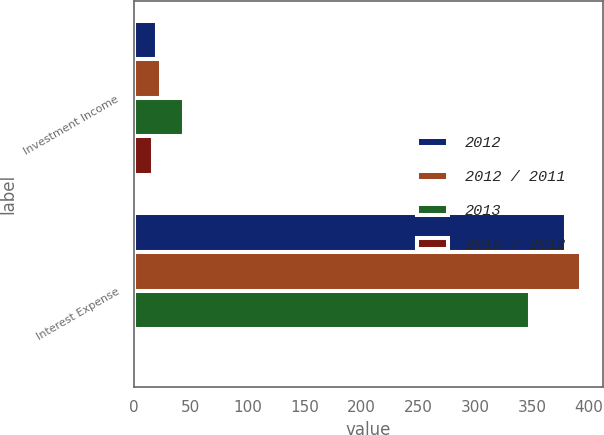<chart> <loc_0><loc_0><loc_500><loc_500><stacked_bar_chart><ecel><fcel>Investment Income<fcel>Interest Expense<nl><fcel>2012<fcel>20<fcel>380<nl><fcel>2012 / 2011<fcel>24<fcel>393<nl><fcel>2013<fcel>44<fcel>348<nl><fcel>2013 / 2012<fcel>16.7<fcel>3.3<nl></chart> 